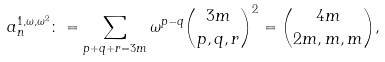<formula> <loc_0><loc_0><loc_500><loc_500>a _ { n } ^ { 1 , \omega , \omega ^ { 2 } } \colon = \sum _ { p + q + r = 3 m } \omega ^ { p - q } \binom { 3 m } { p , q , r } ^ { 2 } = \binom { 4 m } { 2 m , m , m } ,</formula> 